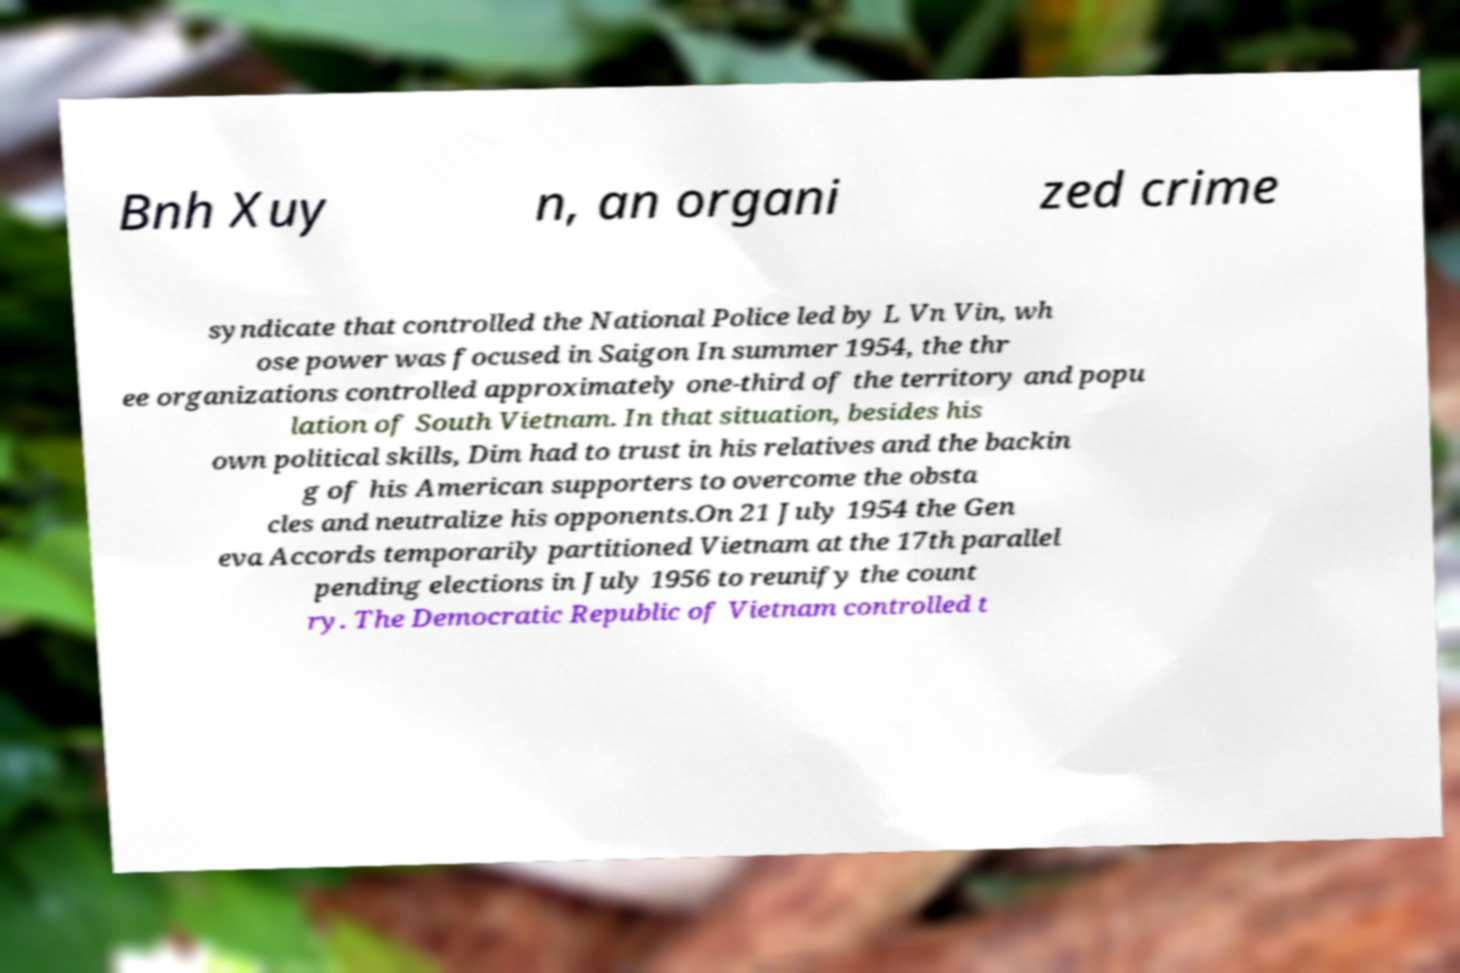Could you assist in decoding the text presented in this image and type it out clearly? Bnh Xuy n, an organi zed crime syndicate that controlled the National Police led by L Vn Vin, wh ose power was focused in Saigon In summer 1954, the thr ee organizations controlled approximately one-third of the territory and popu lation of South Vietnam. In that situation, besides his own political skills, Dim had to trust in his relatives and the backin g of his American supporters to overcome the obsta cles and neutralize his opponents.On 21 July 1954 the Gen eva Accords temporarily partitioned Vietnam at the 17th parallel pending elections in July 1956 to reunify the count ry. The Democratic Republic of Vietnam controlled t 